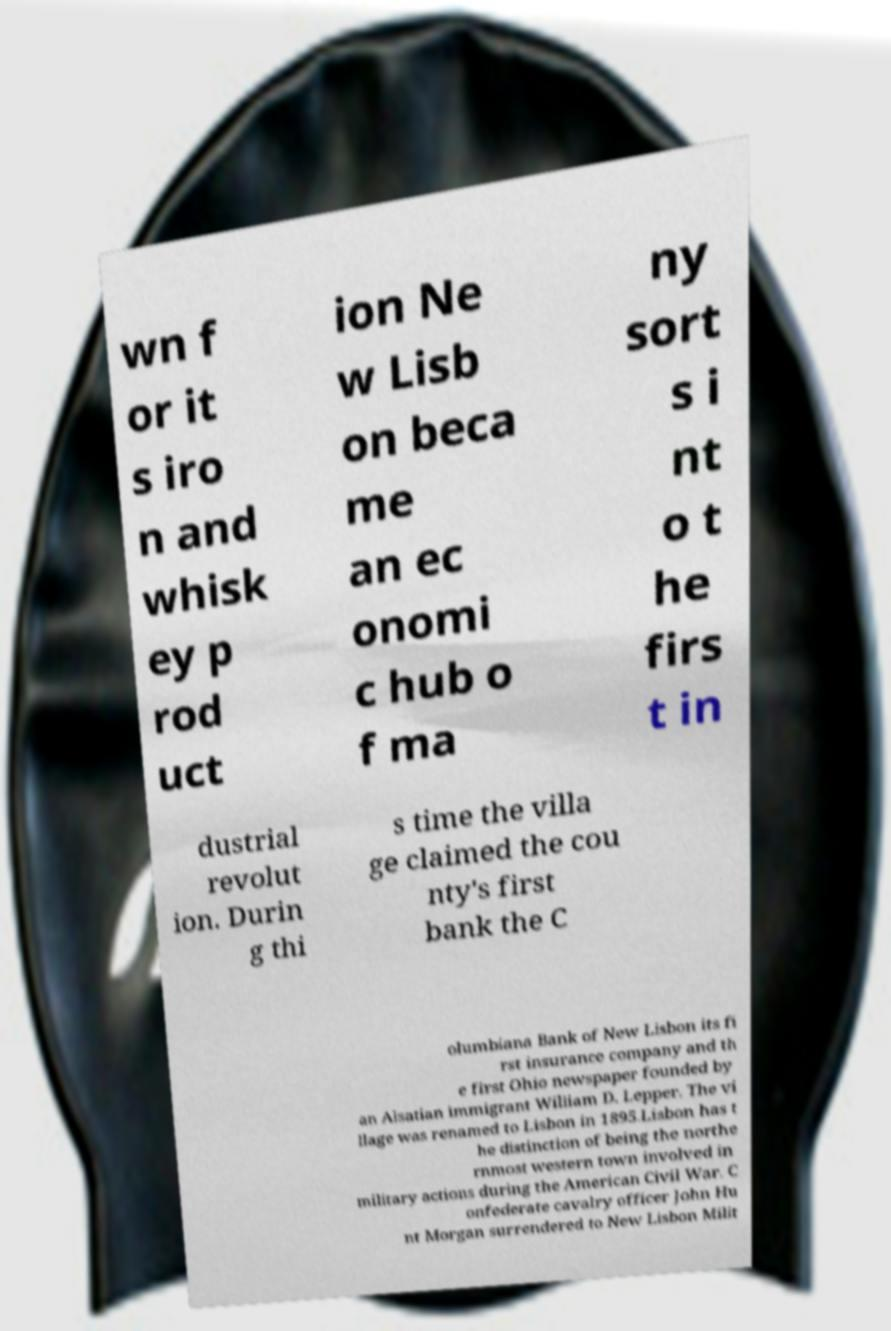For documentation purposes, I need the text within this image transcribed. Could you provide that? wn f or it s iro n and whisk ey p rod uct ion Ne w Lisb on beca me an ec onomi c hub o f ma ny sort s i nt o t he firs t in dustrial revolut ion. Durin g thi s time the villa ge claimed the cou nty's first bank the C olumbiana Bank of New Lisbon its fi rst insurance company and th e first Ohio newspaper founded by an Alsatian immigrant William D. Lepper. The vi llage was renamed to Lisbon in 1895.Lisbon has t he distinction of being the northe rnmost western town involved in military actions during the American Civil War. C onfederate cavalry officer John Hu nt Morgan surrendered to New Lisbon Milit 